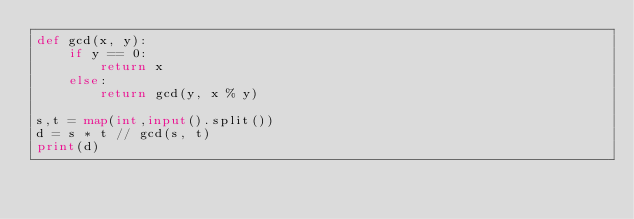Convert code to text. <code><loc_0><loc_0><loc_500><loc_500><_Python_>def gcd(x, y):
    if y == 0:
        return x
    else:
        return gcd(y, x % y) 
    
s,t = map(int,input().split())
d = s * t // gcd(s, t)
print(d)</code> 